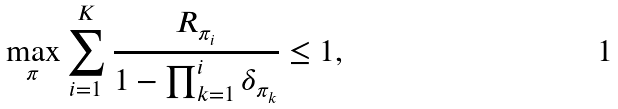Convert formula to latex. <formula><loc_0><loc_0><loc_500><loc_500>\max _ { \pi } \sum _ { i = 1 } ^ { K } \frac { R _ { \pi _ { i } } } { 1 - \prod _ { k = 1 } ^ { i } \delta _ { \pi _ { k } } } \leq 1 ,</formula> 